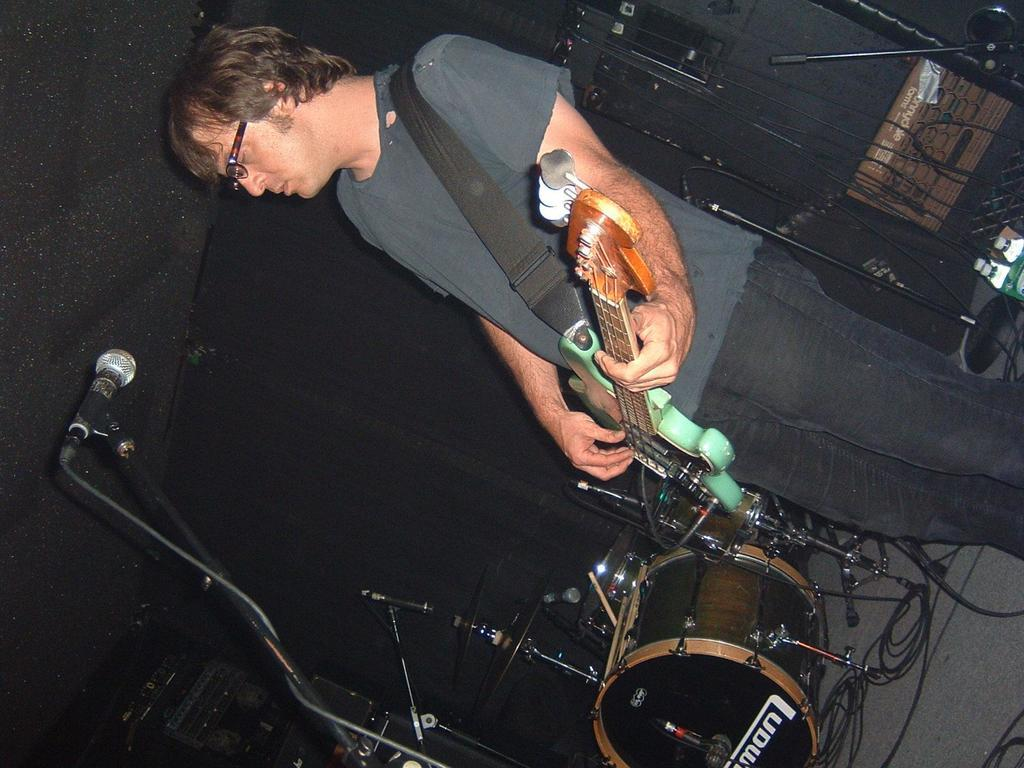What is the main subject of the image? There is a person in the image. What is the person wearing? The person is wearing a guitar. What is in front of the person? There is a microphone in front of the person. What else can be seen around the person? There are musical instruments around the person. What is visible in the background of the image? There is a wall in the background of the image. What type of veil is draped over the guitar in the image? There is no veil present in the image; the person is wearing a guitar. How does the soap contribute to the musical performance in the image? There is no soap present in the image, and it does not contribute to the musical performance. 